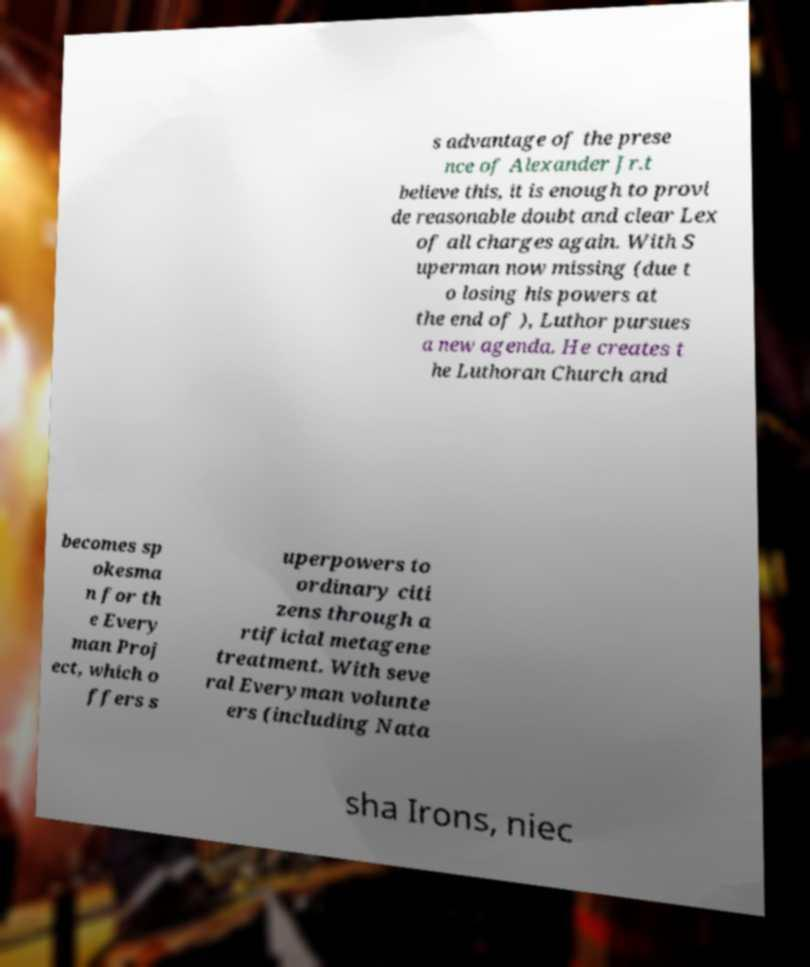I need the written content from this picture converted into text. Can you do that? s advantage of the prese nce of Alexander Jr.t believe this, it is enough to provi de reasonable doubt and clear Lex of all charges again. With S uperman now missing (due t o losing his powers at the end of ), Luthor pursues a new agenda. He creates t he Luthoran Church and becomes sp okesma n for th e Every man Proj ect, which o ffers s uperpowers to ordinary citi zens through a rtificial metagene treatment. With seve ral Everyman volunte ers (including Nata sha Irons, niec 